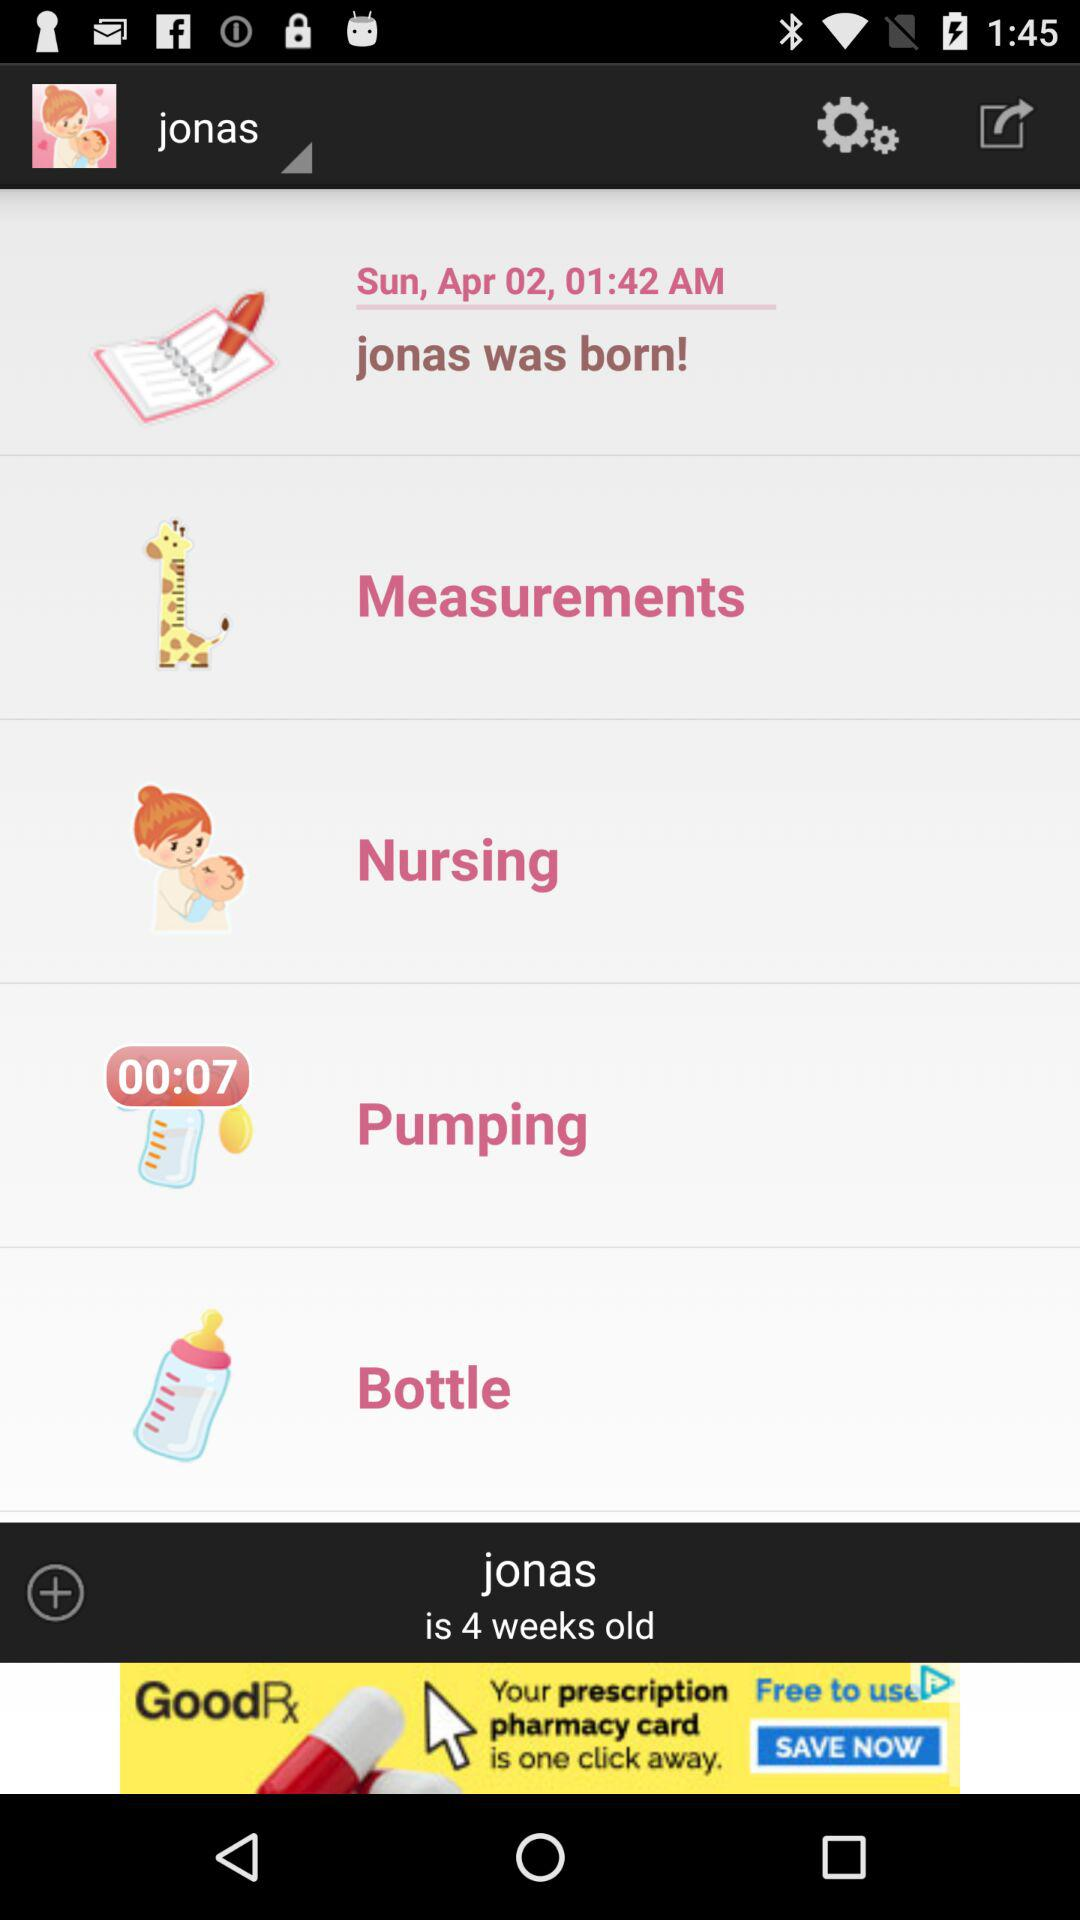What is the date of birth of Jonas? The date of birth is Sunday, April 02. 